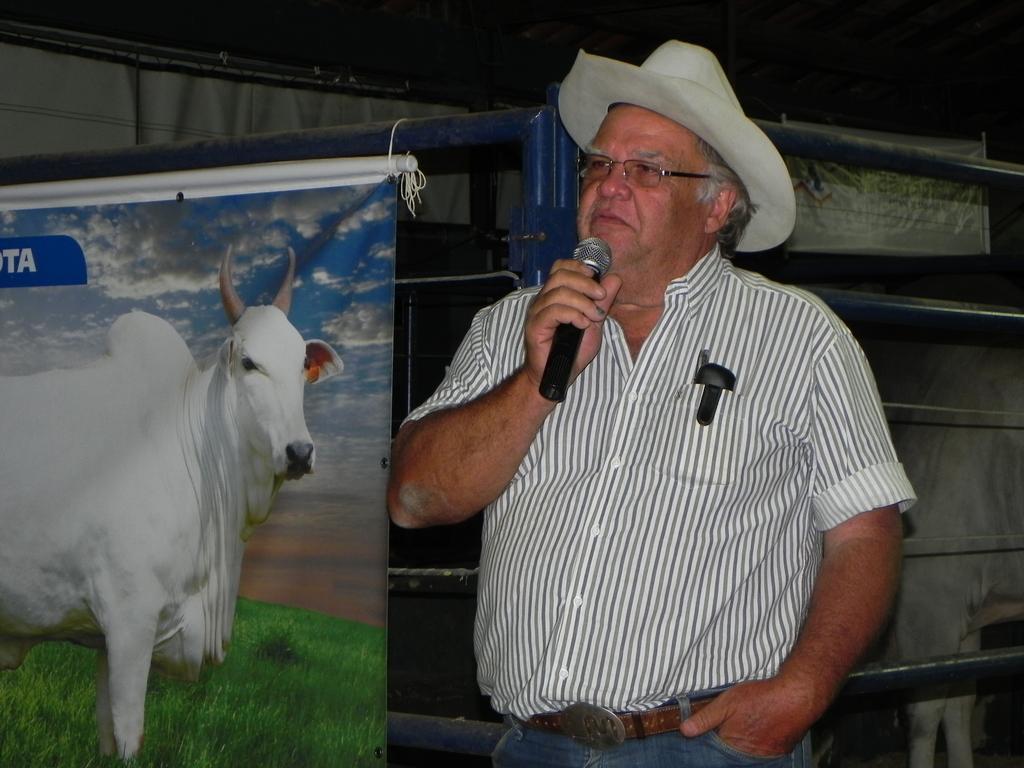Can you describe this image briefly? In this image, we can see a person holding a microphone. We can see some posts with images and text. We can also see some metal objects and also an animal on the right. 